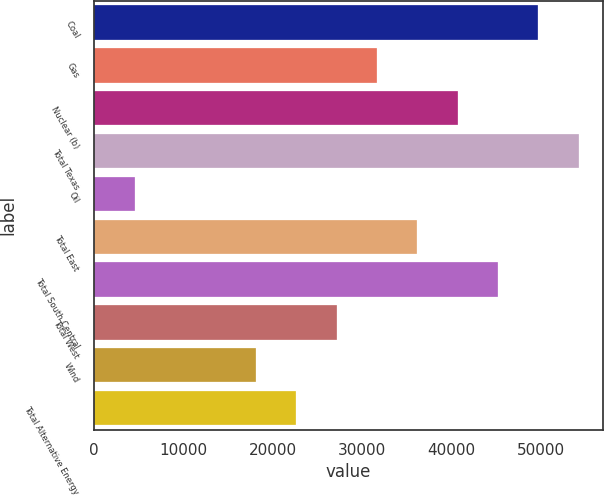<chart> <loc_0><loc_0><loc_500><loc_500><bar_chart><fcel>Coal<fcel>Gas<fcel>Nuclear (b)<fcel>Total Texas<fcel>Oil<fcel>Total East<fcel>Total South Central<fcel>Total West<fcel>Wind<fcel>Total Alternative Energy<nl><fcel>49673.6<fcel>31639.2<fcel>40656.4<fcel>54182.2<fcel>4587.6<fcel>36147.8<fcel>45165<fcel>27130.6<fcel>18113.4<fcel>22622<nl></chart> 